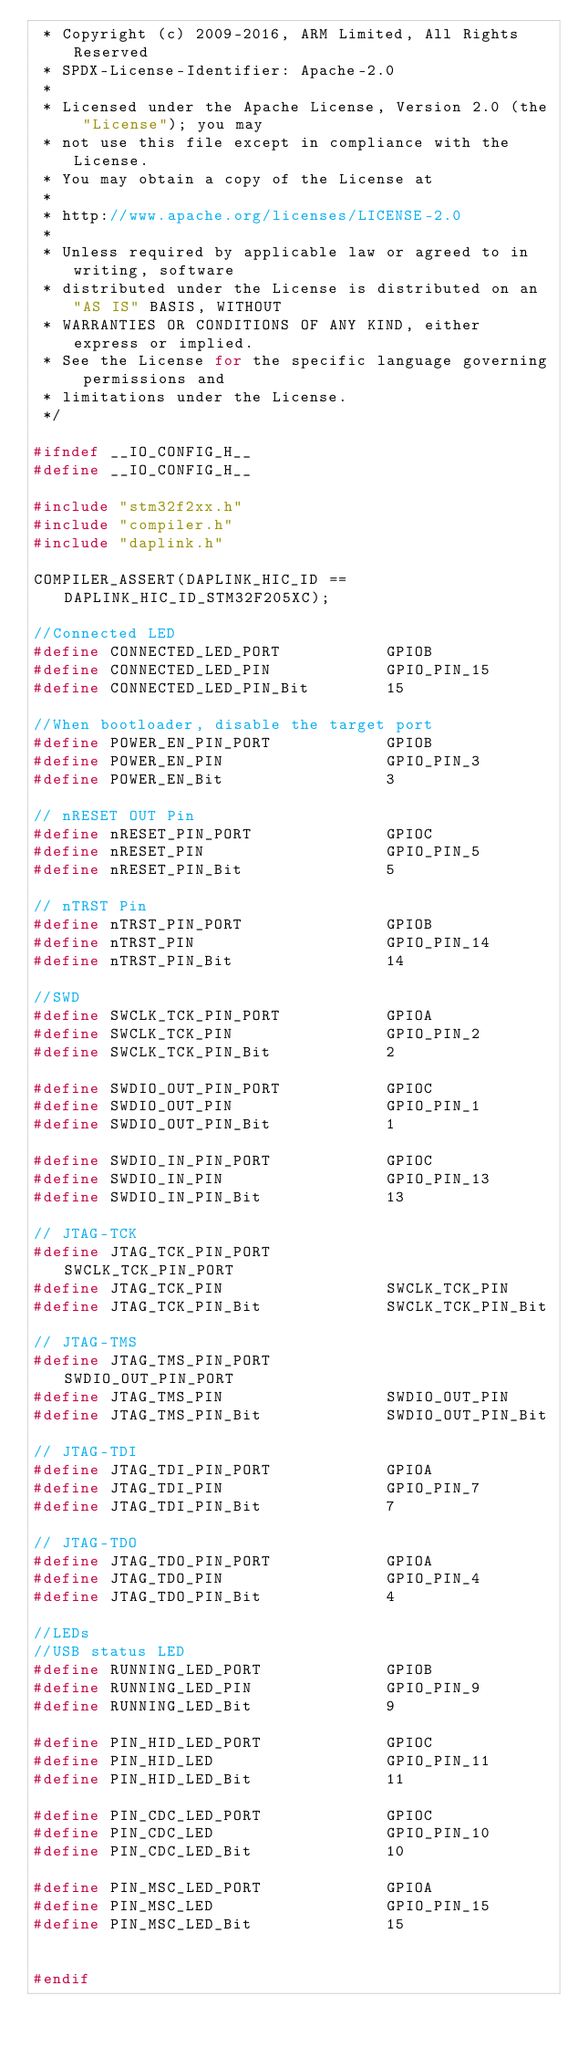Convert code to text. <code><loc_0><loc_0><loc_500><loc_500><_C_> * Copyright (c) 2009-2016, ARM Limited, All Rights Reserved
 * SPDX-License-Identifier: Apache-2.0
 *
 * Licensed under the Apache License, Version 2.0 (the "License"); you may
 * not use this file except in compliance with the License.
 * You may obtain a copy of the License at
 *
 * http://www.apache.org/licenses/LICENSE-2.0
 *
 * Unless required by applicable law or agreed to in writing, software
 * distributed under the License is distributed on an "AS IS" BASIS, WITHOUT
 * WARRANTIES OR CONDITIONS OF ANY KIND, either express or implied.
 * See the License for the specific language governing permissions and
 * limitations under the License.
 */

#ifndef __IO_CONFIG_H__
#define __IO_CONFIG_H__

#include "stm32f2xx.h"
#include "compiler.h"
#include "daplink.h"

COMPILER_ASSERT(DAPLINK_HIC_ID == DAPLINK_HIC_ID_STM32F205XC);

//Connected LED
#define CONNECTED_LED_PORT           GPIOB
#define CONNECTED_LED_PIN            GPIO_PIN_15
#define CONNECTED_LED_PIN_Bit        15

//When bootloader, disable the target port
#define POWER_EN_PIN_PORT            GPIOB
#define POWER_EN_PIN                 GPIO_PIN_3
#define POWER_EN_Bit                 3

// nRESET OUT Pin
#define nRESET_PIN_PORT              GPIOC
#define nRESET_PIN                   GPIO_PIN_5
#define nRESET_PIN_Bit               5

// nTRST Pin
#define nTRST_PIN_PORT               GPIOB
#define nTRST_PIN                    GPIO_PIN_14
#define nTRST_PIN_Bit                14

//SWD
#define SWCLK_TCK_PIN_PORT           GPIOA
#define SWCLK_TCK_PIN                GPIO_PIN_2
#define SWCLK_TCK_PIN_Bit            2

#define SWDIO_OUT_PIN_PORT           GPIOC
#define SWDIO_OUT_PIN                GPIO_PIN_1
#define SWDIO_OUT_PIN_Bit            1

#define SWDIO_IN_PIN_PORT            GPIOC
#define SWDIO_IN_PIN                 GPIO_PIN_13
#define SWDIO_IN_PIN_Bit             13

// JTAG-TCK
#define JTAG_TCK_PIN_PORT            SWCLK_TCK_PIN_PORT
#define JTAG_TCK_PIN                 SWCLK_TCK_PIN
#define JTAG_TCK_PIN_Bit             SWCLK_TCK_PIN_Bit

// JTAG-TMS
#define JTAG_TMS_PIN_PORT            SWDIO_OUT_PIN_PORT
#define JTAG_TMS_PIN                 SWDIO_OUT_PIN
#define JTAG_TMS_PIN_Bit             SWDIO_OUT_PIN_Bit

// JTAG-TDI
#define JTAG_TDI_PIN_PORT            GPIOA
#define JTAG_TDI_PIN                 GPIO_PIN_7
#define JTAG_TDI_PIN_Bit             7

// JTAG-TDO
#define JTAG_TDO_PIN_PORT            GPIOA
#define JTAG_TDO_PIN                 GPIO_PIN_4
#define JTAG_TDO_PIN_Bit             4

//LEDs
//USB status LED
#define RUNNING_LED_PORT             GPIOB
#define RUNNING_LED_PIN              GPIO_PIN_9
#define RUNNING_LED_Bit              9

#define PIN_HID_LED_PORT             GPIOC
#define PIN_HID_LED                  GPIO_PIN_11
#define PIN_HID_LED_Bit              11

#define PIN_CDC_LED_PORT             GPIOC
#define PIN_CDC_LED                  GPIO_PIN_10
#define PIN_CDC_LED_Bit              10

#define PIN_MSC_LED_PORT             GPIOA
#define PIN_MSC_LED                  GPIO_PIN_15
#define PIN_MSC_LED_Bit              15


#endif
</code> 